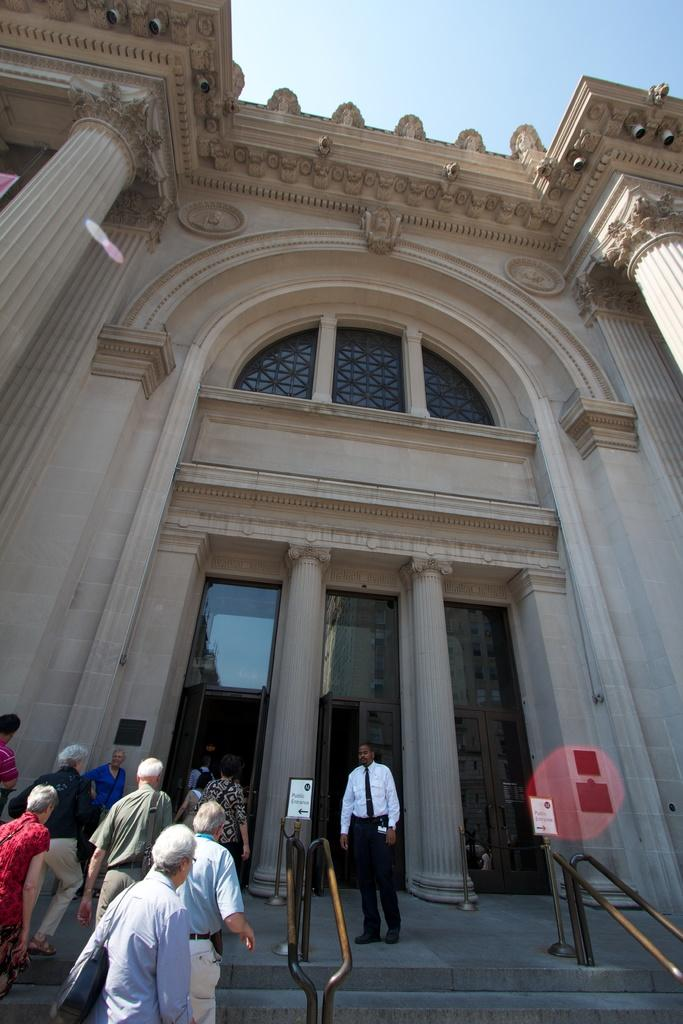What type of building is in the image? There is a cream-colored building in the image. What are the people in the image doing? The people are on the stairs in the image. What can be seen in the background of the image? The sky is visible in the background of the image. What type of skin condition is visible on the people in the image? There is no information about any skin conditions visible on the people in the image. 